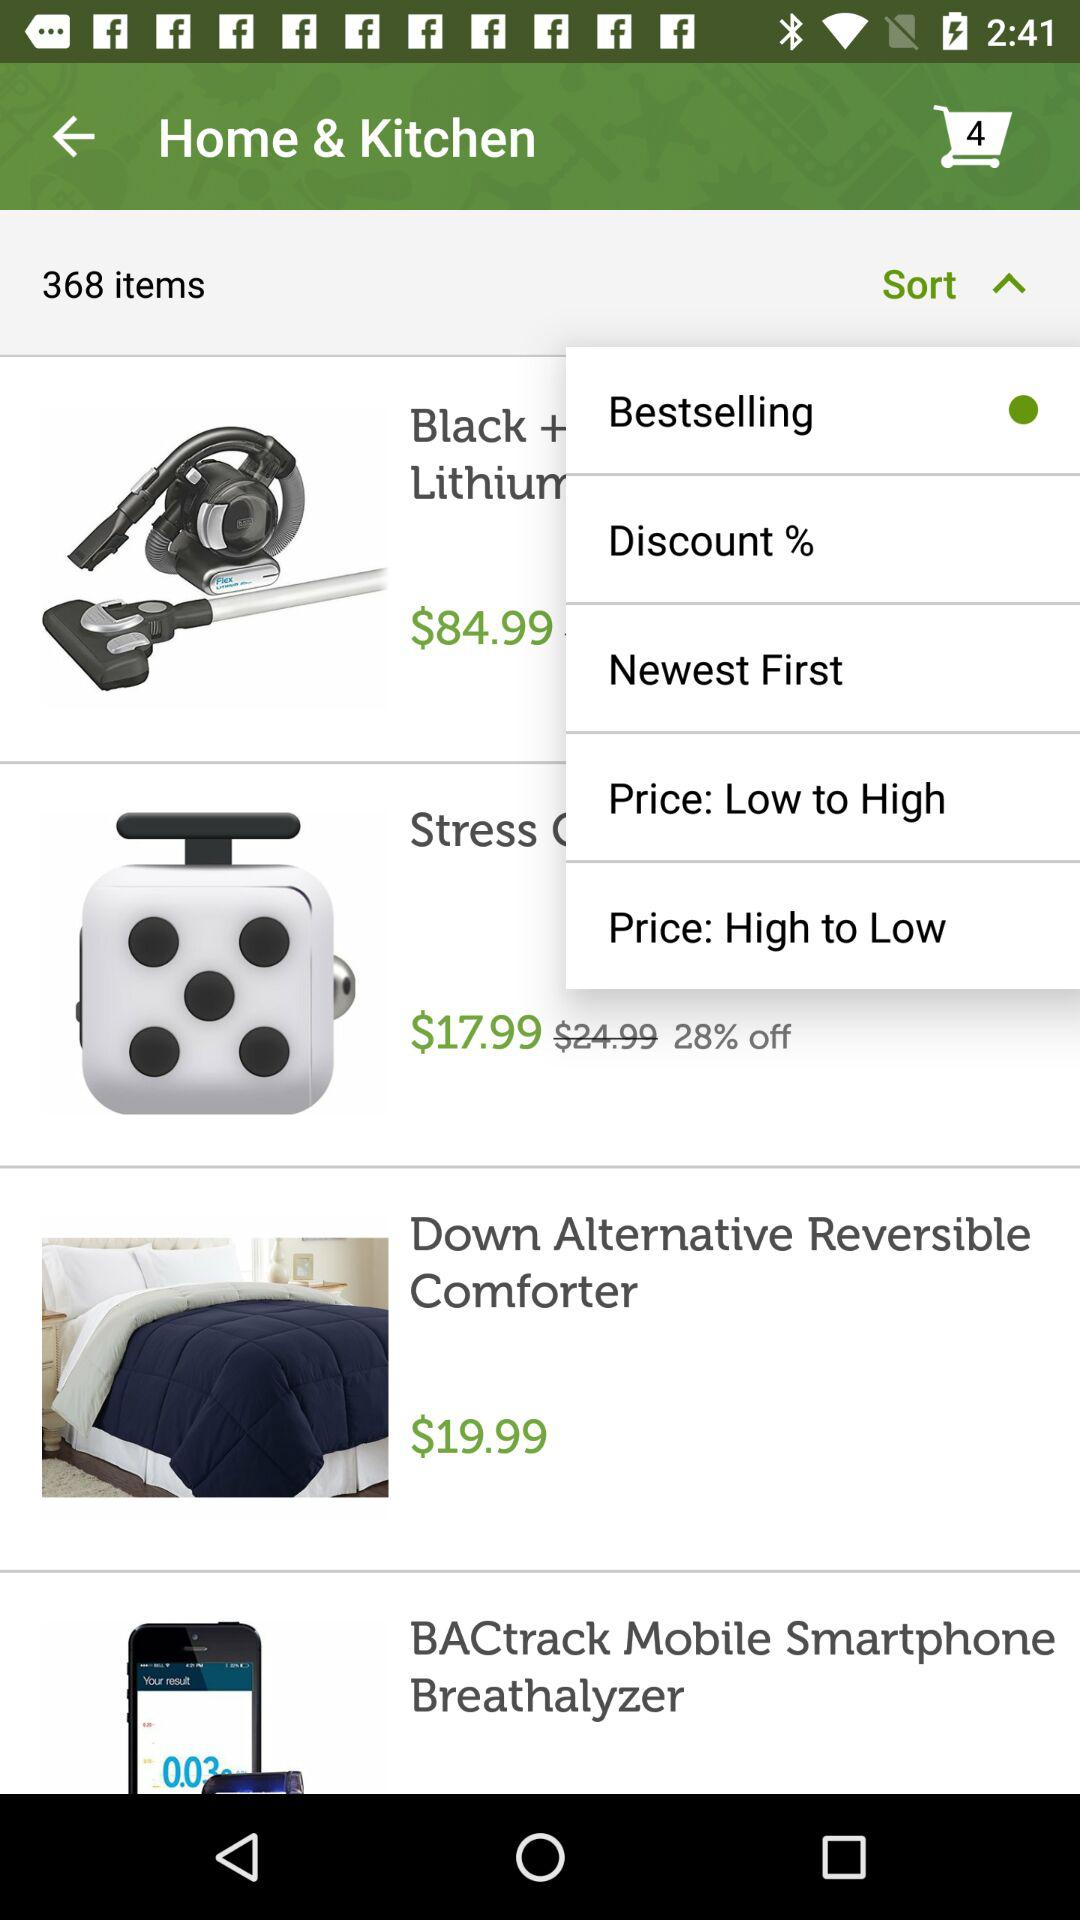How many items are there in the Home & Kitchen category?
Answer the question using a single word or phrase. 368 